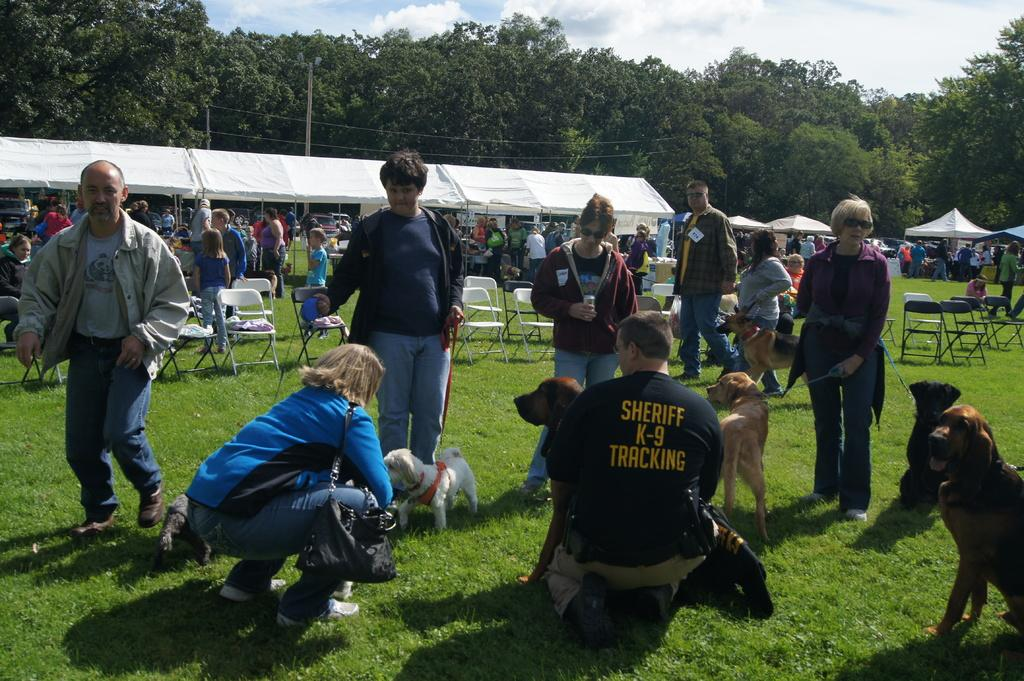Who is present in the image? There are people in the image. What are some of the people doing in the image? Some people are standing with their dogs. What type of furniture can be seen in the image? There are chairs in the image. What type of temporary shelter is present in the image? There are tents in the image. What type of natural vegetation is present in the image? There are trees in the image. What type of substance is being sold at the airport in the image? There is no airport present in the image, and therefore no substance is being sold. How many cushions are visible on the chairs in the image? There is no mention of cushions on the chairs in the image, so we cannot determine their presence or quantity. 